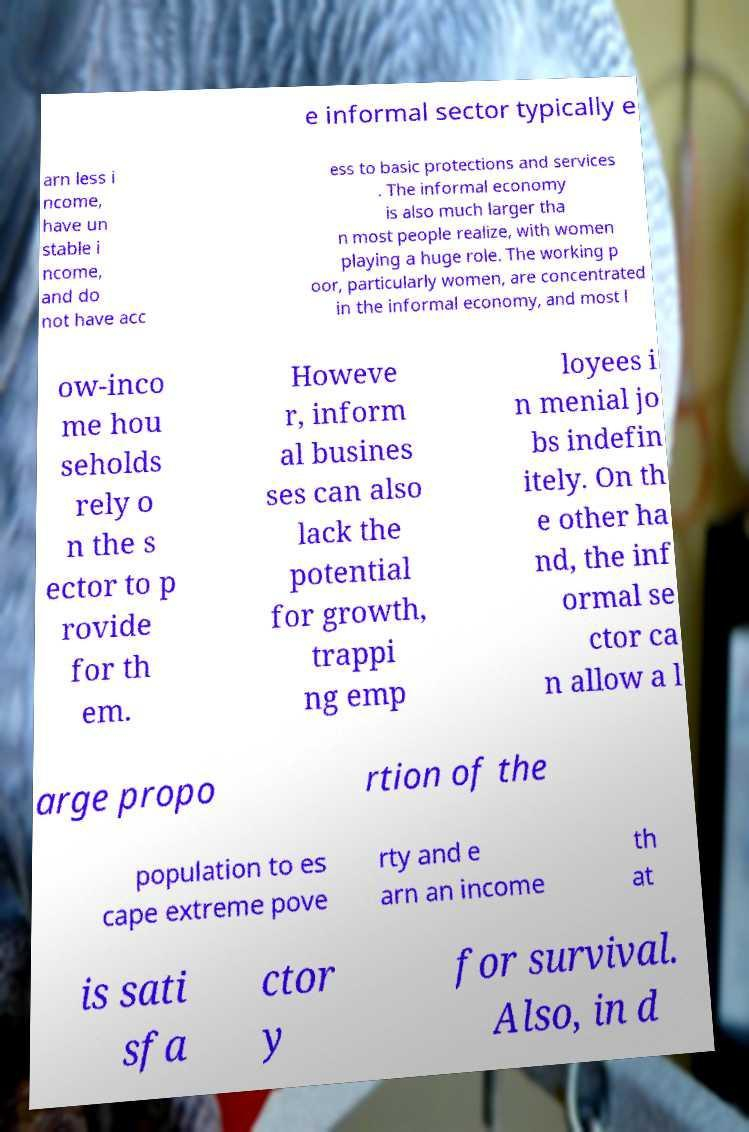Can you accurately transcribe the text from the provided image for me? e informal sector typically e arn less i ncome, have un stable i ncome, and do not have acc ess to basic protections and services . The informal economy is also much larger tha n most people realize, with women playing a huge role. The working p oor, particularly women, are concentrated in the informal economy, and most l ow-inco me hou seholds rely o n the s ector to p rovide for th em. Howeve r, inform al busines ses can also lack the potential for growth, trappi ng emp loyees i n menial jo bs indefin itely. On th e other ha nd, the inf ormal se ctor ca n allow a l arge propo rtion of the population to es cape extreme pove rty and e arn an income th at is sati sfa ctor y for survival. Also, in d 